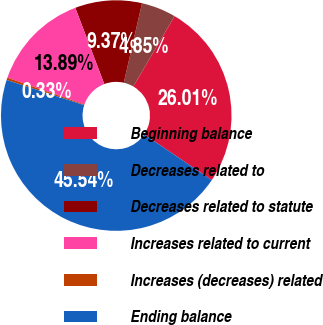Convert chart to OTSL. <chart><loc_0><loc_0><loc_500><loc_500><pie_chart><fcel>Beginning balance<fcel>Decreases related to<fcel>Decreases related to statute<fcel>Increases related to current<fcel>Increases (decreases) related<fcel>Ending balance<nl><fcel>26.01%<fcel>4.85%<fcel>9.37%<fcel>13.89%<fcel>0.33%<fcel>45.54%<nl></chart> 